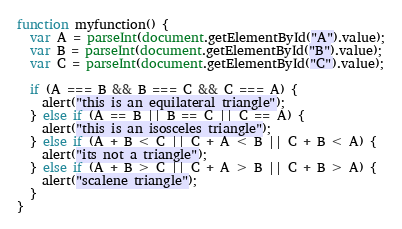Convert code to text. <code><loc_0><loc_0><loc_500><loc_500><_JavaScript_>function myfunction() {
  var A = parseInt(document.getElementById("A").value);
  var B = parseInt(document.getElementById("B").value);
  var C = parseInt(document.getElementById("C").value);

  if (A === B && B === C && C === A) {
    alert("this is an equilateral triangle");
  } else if (A == B || B == C || C == A) {
    alert("this is an isosceles triangle");
  } else if (A + B < C || C + A < B || C + B < A) {
    alert("its not a triangle");
  } else if (A + B > C || C + A > B || C + B > A) {
    alert("scalene triangle");
  }
}
</code> 